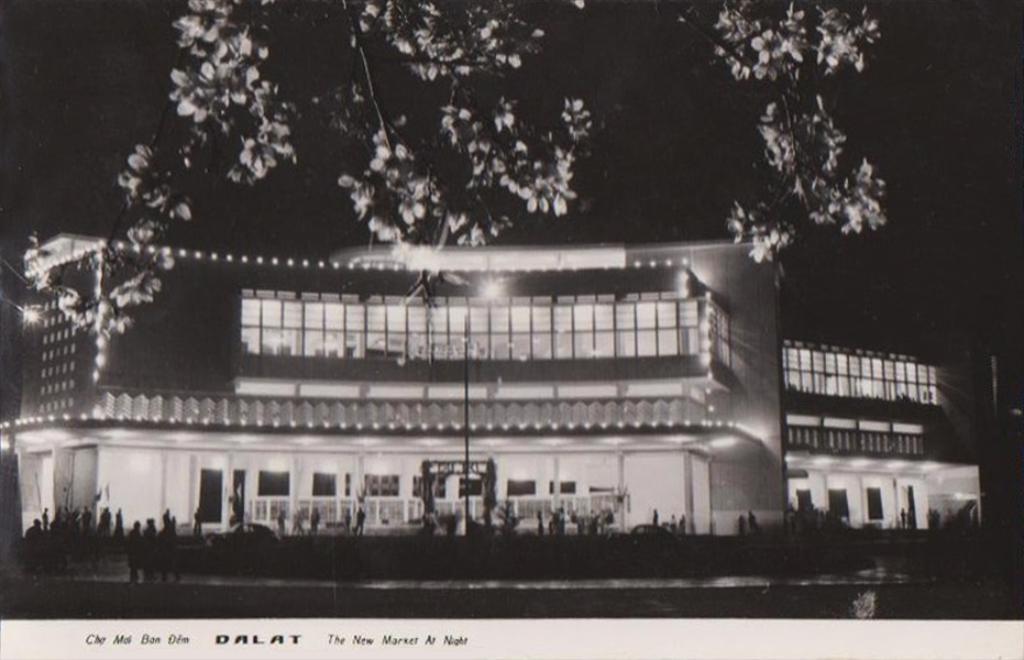Please provide a concise description of this image. This picture might be taken from outside of the building. In this image, we can see group of people, statue. In the background, we can see a building, windows. At the top, we can see trees and black color. 